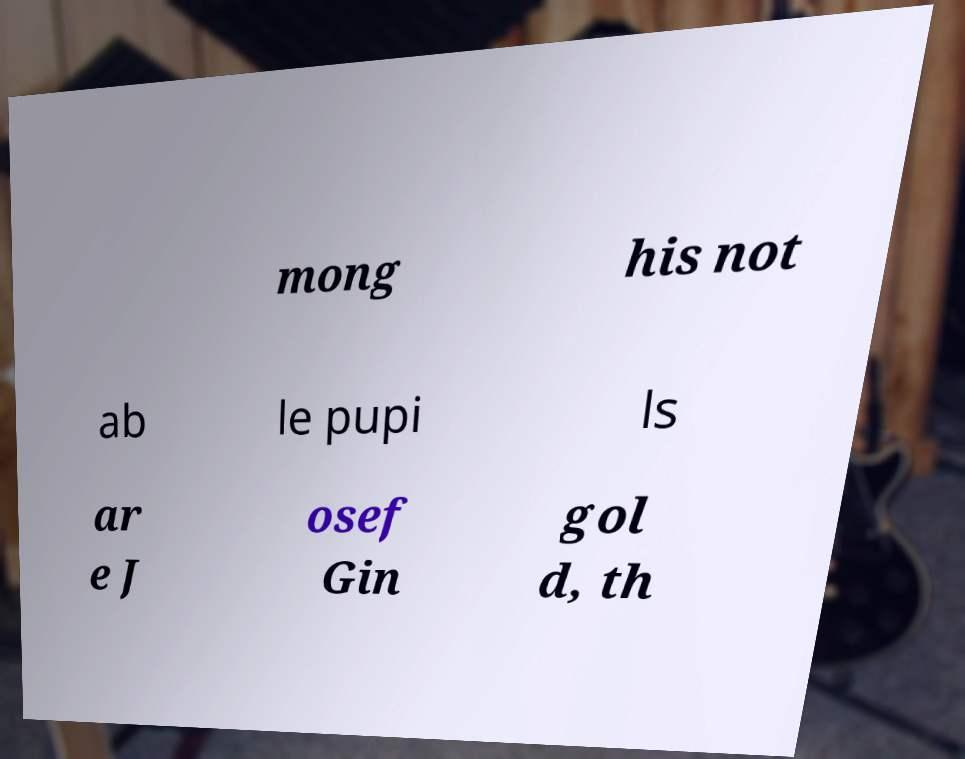Please identify and transcribe the text found in this image. mong his not ab le pupi ls ar e J osef Gin gol d, th 